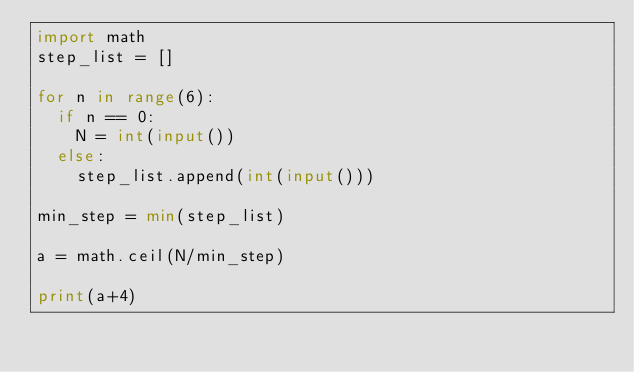Convert code to text. <code><loc_0><loc_0><loc_500><loc_500><_Python_>import math 
step_list = []

for n in range(6):
  if n == 0:
    N = int(input())
  else:
    step_list.append(int(input()))

min_step = min(step_list)

a = math.ceil(N/min_step)

print(a+4)</code> 